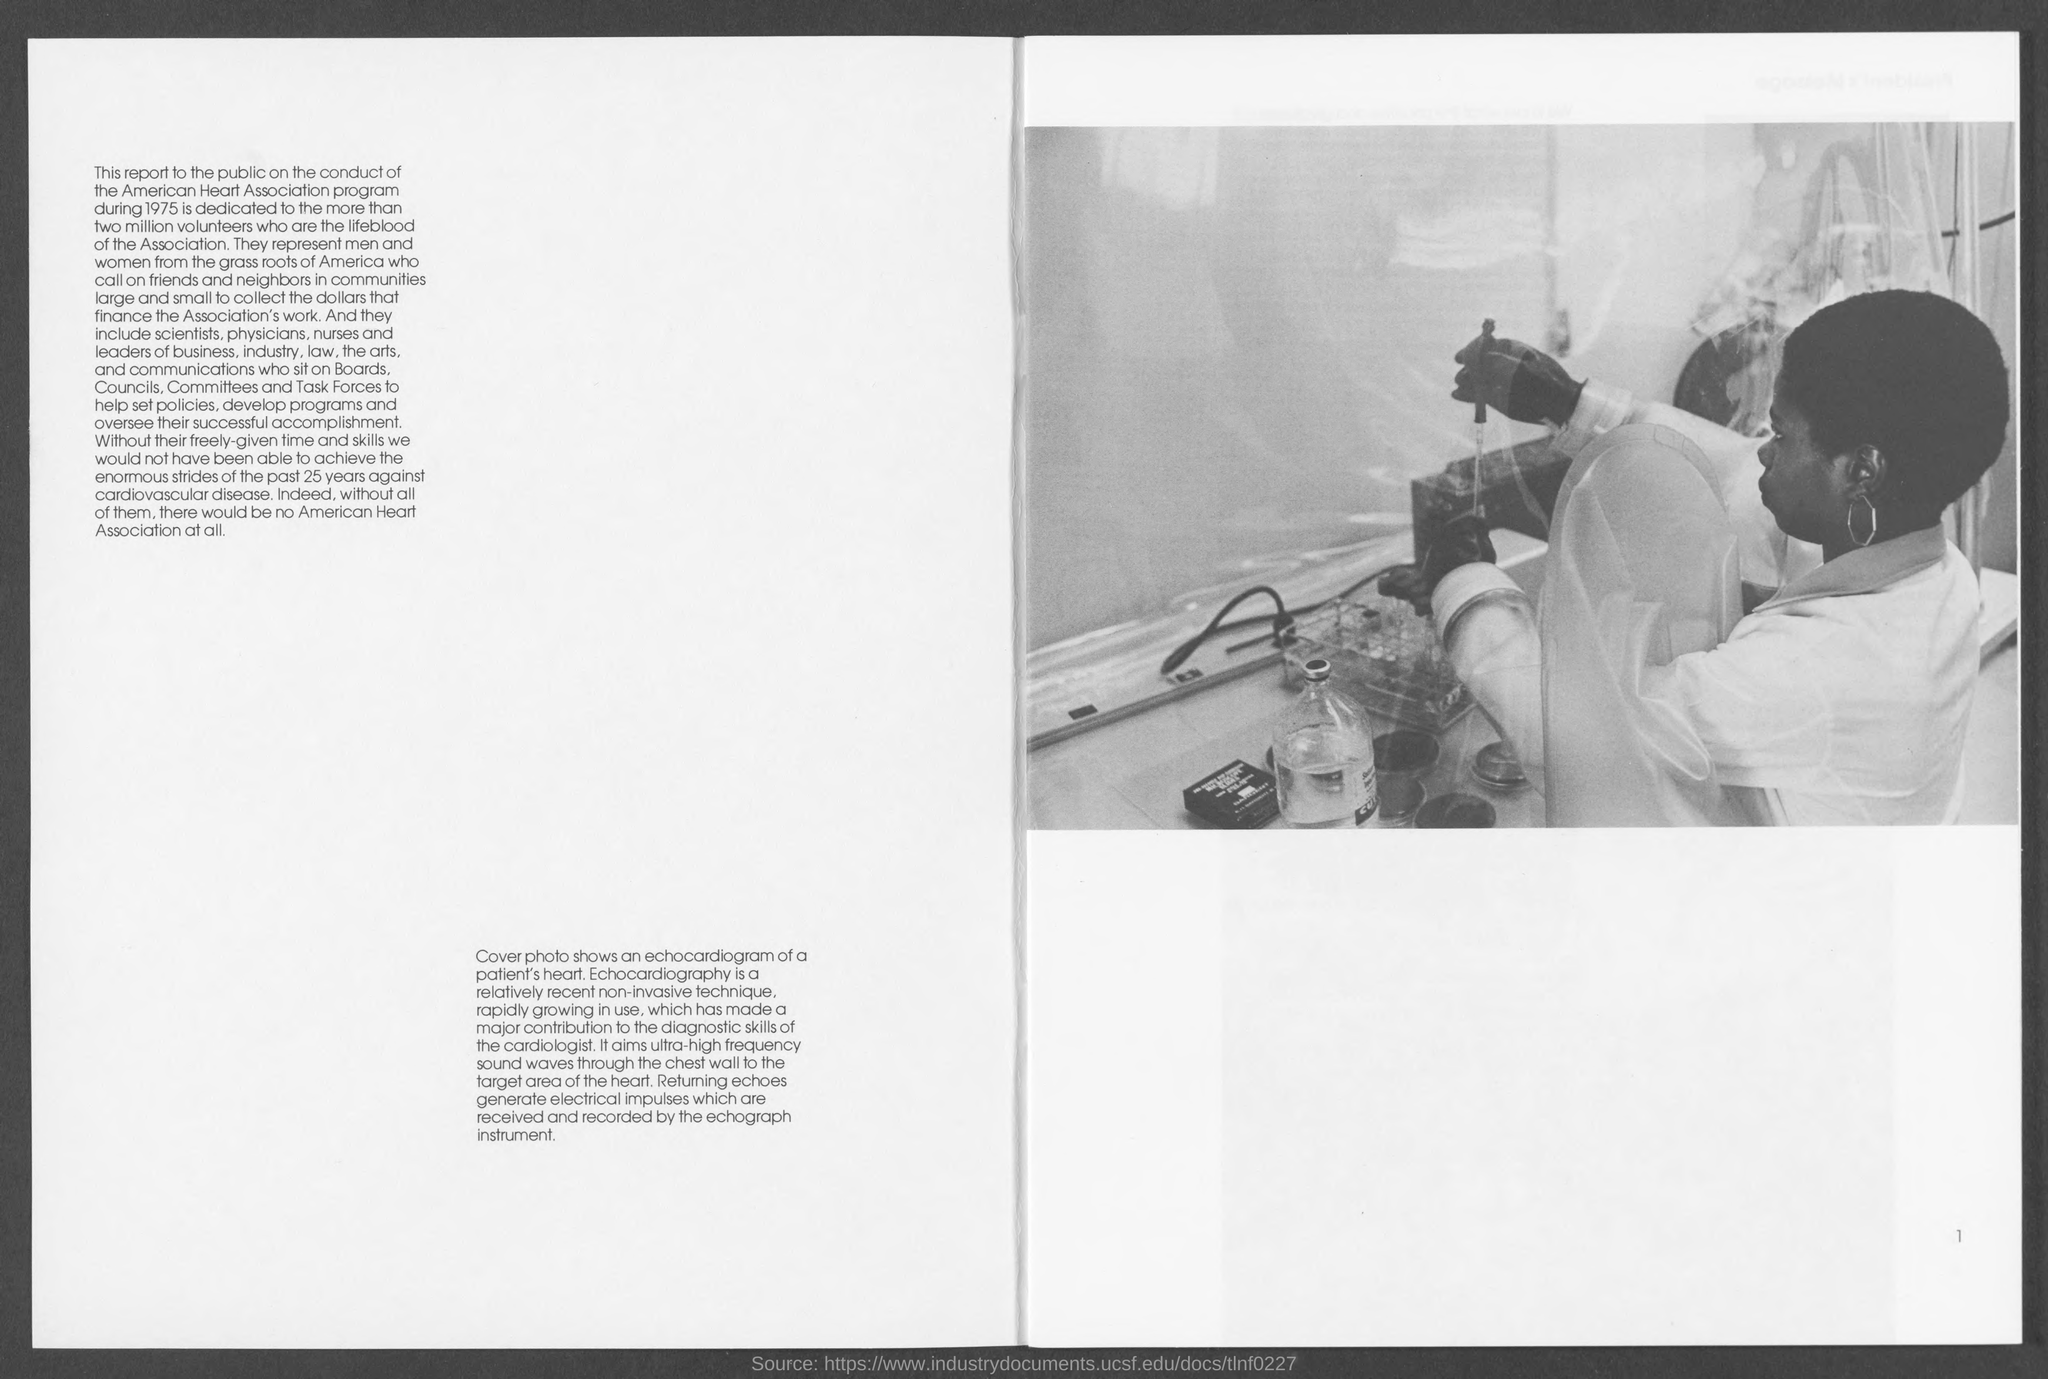What does the cover photo in this document show?
Offer a terse response. An echocardiogram of a patient's heart. Which non-invasive technique has made a major contribution to the diagnostic skillls of the cardiologist?
Offer a very short reply. Echocardiography. What waves  Echocardiography  use ?
Offer a terse response. Ultra-high frequency sound waves. 